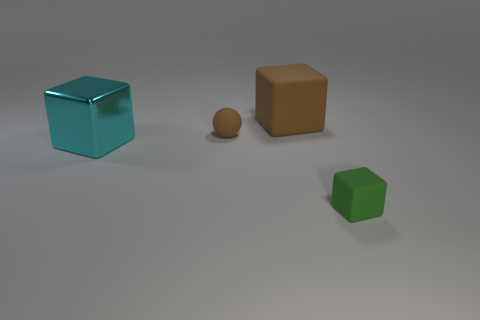Add 2 small cyan shiny cylinders. How many objects exist? 6 Subtract all balls. How many objects are left? 3 Add 2 tiny gray rubber cylinders. How many tiny gray rubber cylinders exist? 2 Subtract 0 cyan cylinders. How many objects are left? 4 Subtract all metal things. Subtract all big brown rubber blocks. How many objects are left? 2 Add 1 balls. How many balls are left? 2 